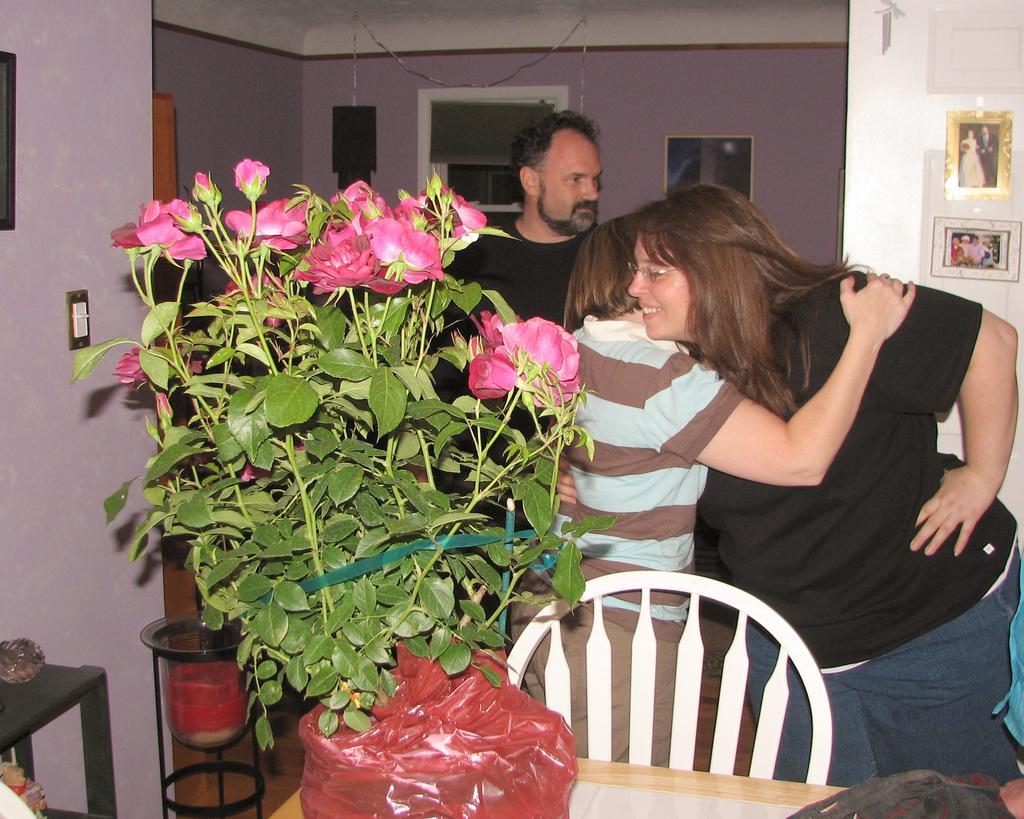How would you summarize this image in a sentence or two? In this image we can see a table and a chair. On the table there is a packet with rose plant and flowers. In the back there are few people. Also there are walls with photo frames. There is an object hangs on the ceiling. On the right side there is a table and some other object. 